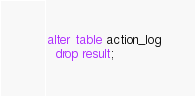Convert code to text. <code><loc_0><loc_0><loc_500><loc_500><_SQL_>alter table action_log
  drop result;</code> 